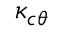Convert formula to latex. <formula><loc_0><loc_0><loc_500><loc_500>\kappa _ { c \theta }</formula> 